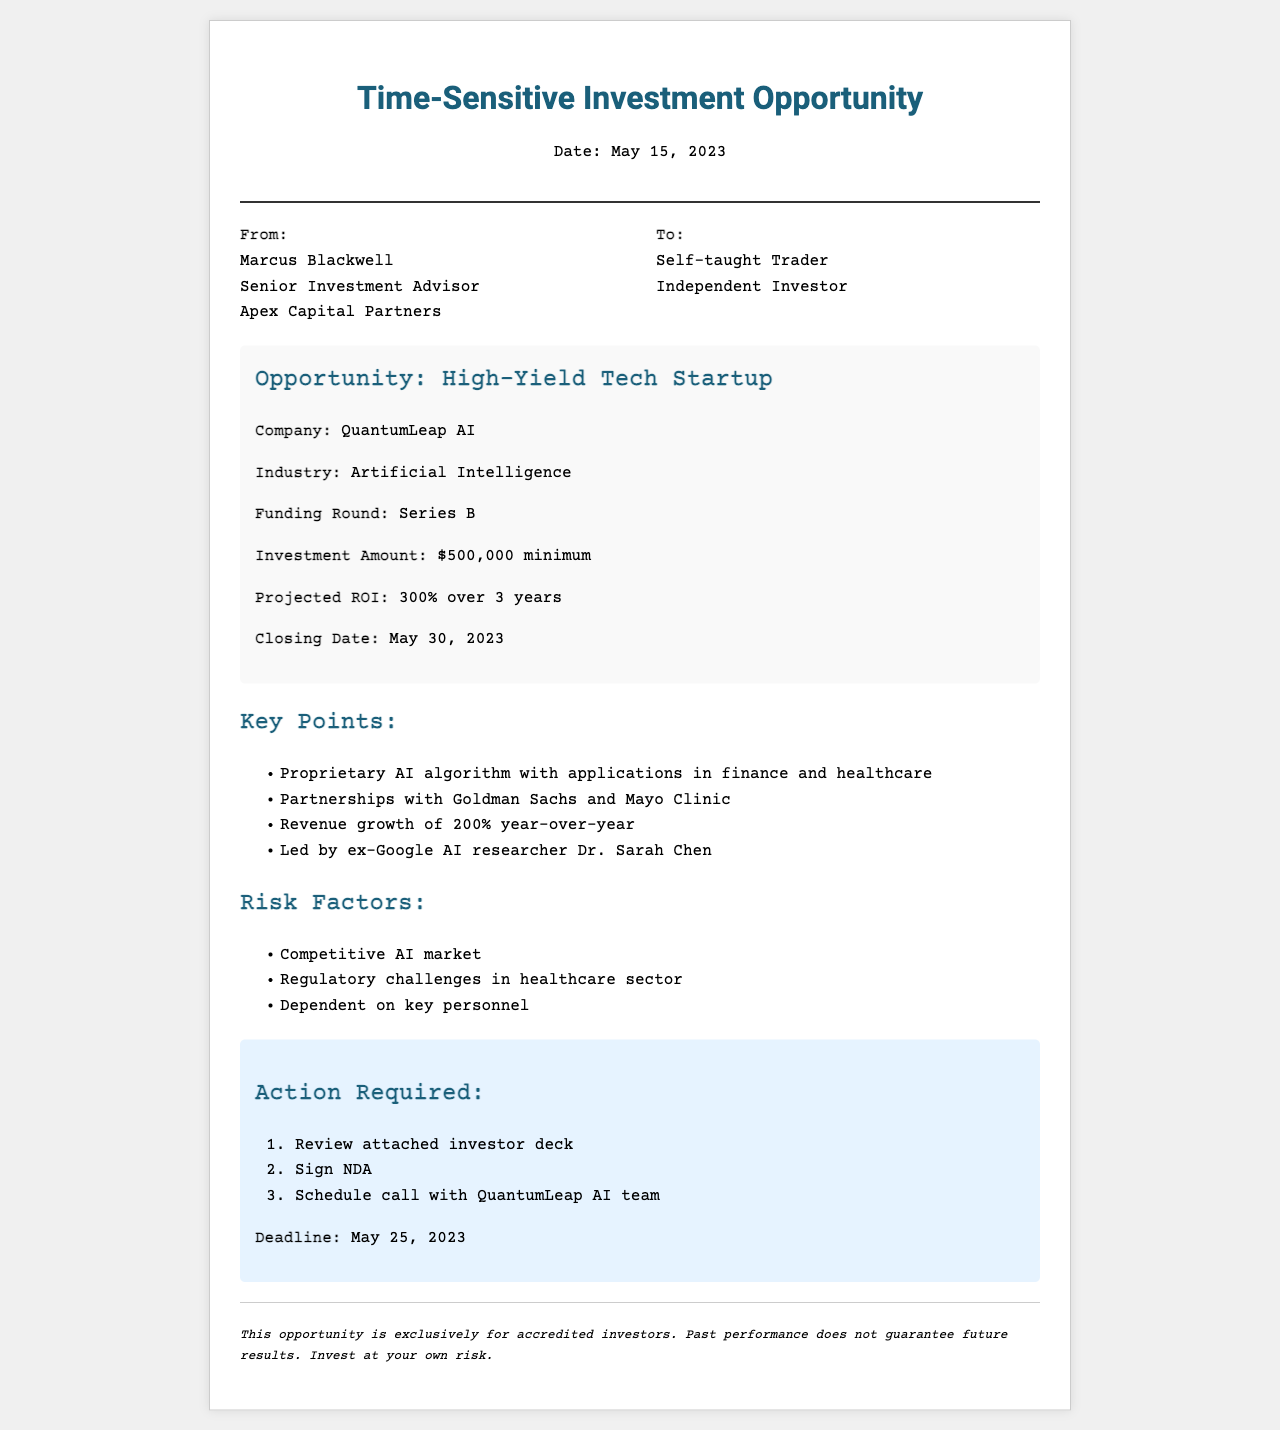What is the name of the company involved in the investment opportunity? The name of the company is mentioned in the opportunity details section of the document.
Answer: QuantumLeap AI What is the projected ROI for the investment? The projected ROI is specified under the opportunity details section.
Answer: 300% Who is the Senior Investment Advisor? The name of the Senior Investment Advisor is listed in the sender section of the document.
Answer: Marcus Blackwell When is the closing date for the investment? The closing date is provided in the opportunity details section of the fax.
Answer: May 30, 2023 What is the minimum investment amount required? The minimum investment amount is included in the opportunity details section.
Answer: $500,000 What are the revenue growth statistics for the company? The revenue growth statistics are mentioned under the key points related to the company’s performance.
Answer: 200% year-over-year What are the key partnerships mentioned in the document? The key partnerships are listed in the key points section, highlighting collaborations that strengthen the company's credibility.
Answer: Goldman Sachs and Mayo Clinic What is one of the risk factors listed in the document? The risk factors are outlined in a specific section of the fax, identifying potential challenges.
Answer: Competitive AI market What is required of investors by May 25, 2023? The action required section specifies actions investors need to take before the deadline.
Answer: Sign NDA 